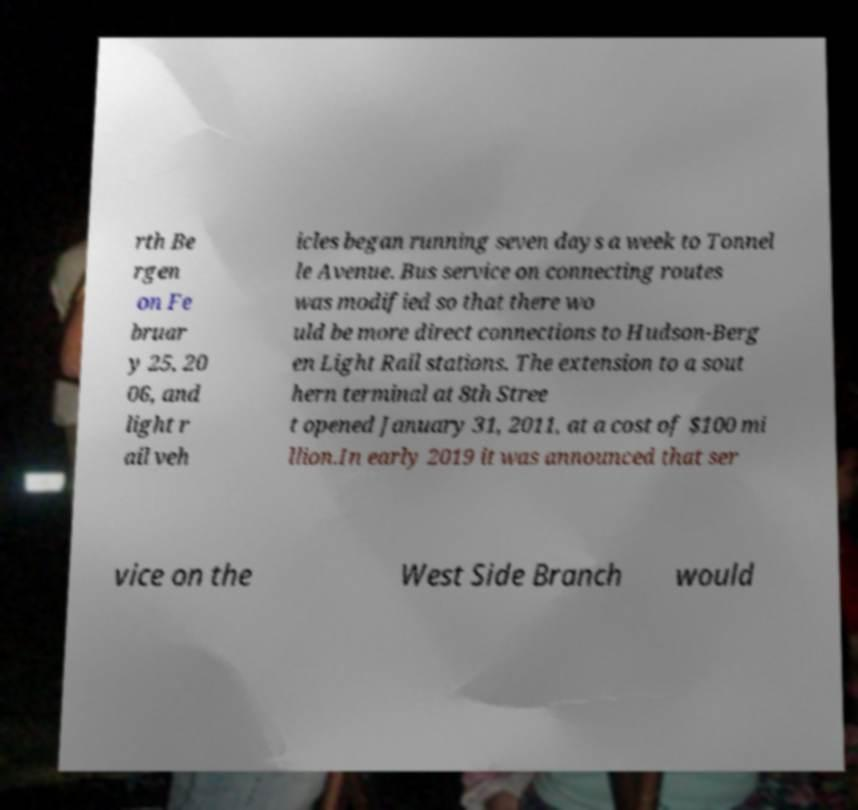What messages or text are displayed in this image? I need them in a readable, typed format. rth Be rgen on Fe bruar y 25, 20 06, and light r ail veh icles began running seven days a week to Tonnel le Avenue. Bus service on connecting routes was modified so that there wo uld be more direct connections to Hudson-Berg en Light Rail stations. The extension to a sout hern terminal at 8th Stree t opened January 31, 2011, at a cost of $100 mi llion.In early 2019 it was announced that ser vice on the West Side Branch would 